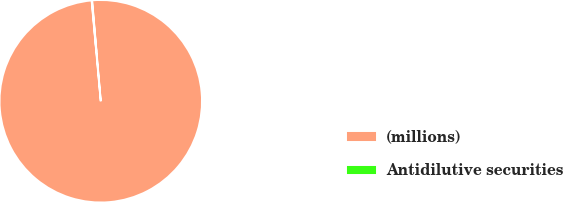Convert chart to OTSL. <chart><loc_0><loc_0><loc_500><loc_500><pie_chart><fcel>(millions)<fcel>Antidilutive securities<nl><fcel>99.92%<fcel>0.08%<nl></chart> 